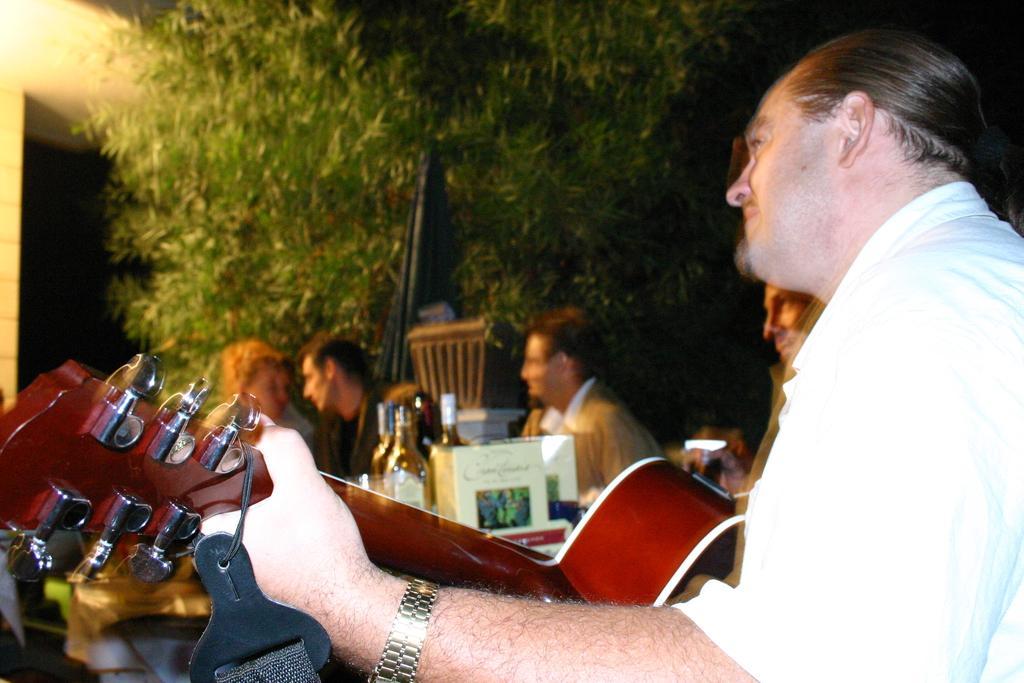Could you give a brief overview of what you see in this image? In the front there is man with white shirt. He is playing guitar. There is a watch to his hand. And there are some people sitting. There are some bottles and two carry bags. And to the top we can see a tree and a black object. 